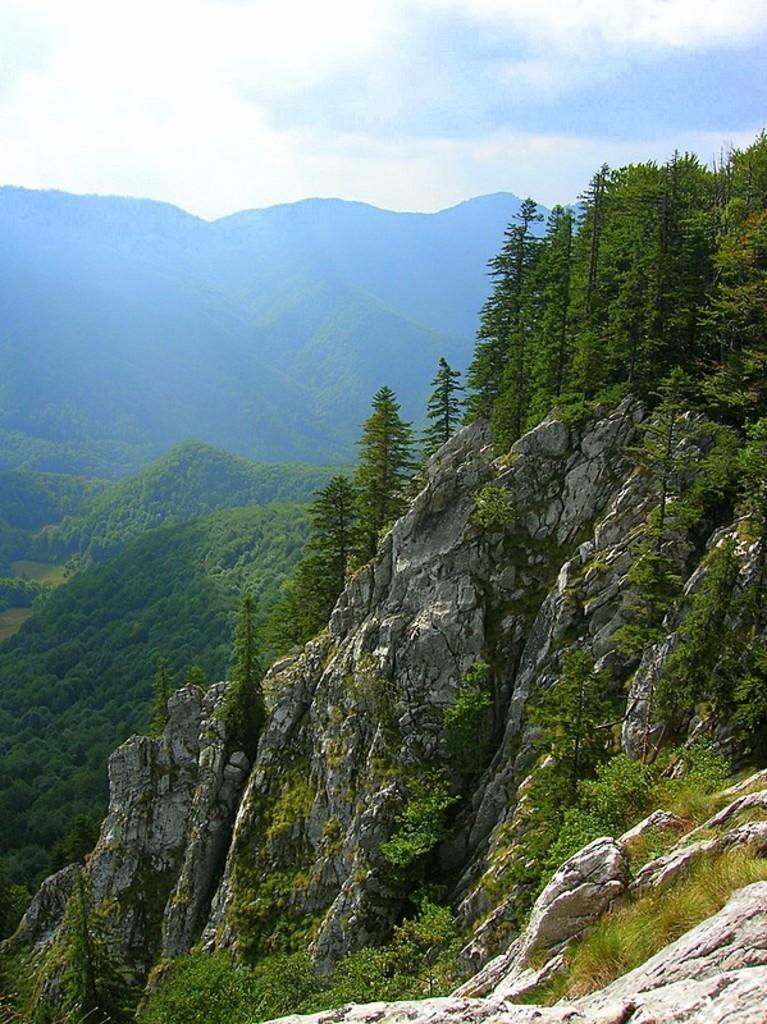Describe this image in one or two sentences. In this image there are mountains, on that mountains there are trees, in the background there is a sky. 